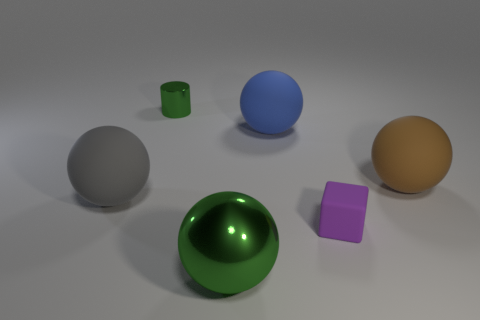What shape is the thing that is the same color as the metallic ball?
Offer a terse response. Cylinder. What number of big gray balls are there?
Make the answer very short. 1. Are the small cube that is on the left side of the brown object and the green object in front of the large blue rubber object made of the same material?
Offer a terse response. No. The gray thing that is made of the same material as the block is what size?
Your answer should be very brief. Large. The tiny object that is in front of the big gray object has what shape?
Make the answer very short. Cube. Does the metal object on the left side of the big green object have the same color as the metal object that is in front of the green shiny cylinder?
Provide a succinct answer. Yes. There is a shiny object that is the same color as the metal ball; what size is it?
Make the answer very short. Small. Is there a matte sphere?
Offer a very short reply. Yes. What shape is the matte object that is in front of the matte thing that is on the left side of the green thing in front of the large gray sphere?
Make the answer very short. Cube. How many blue matte objects are left of the small green thing?
Make the answer very short. 0. 